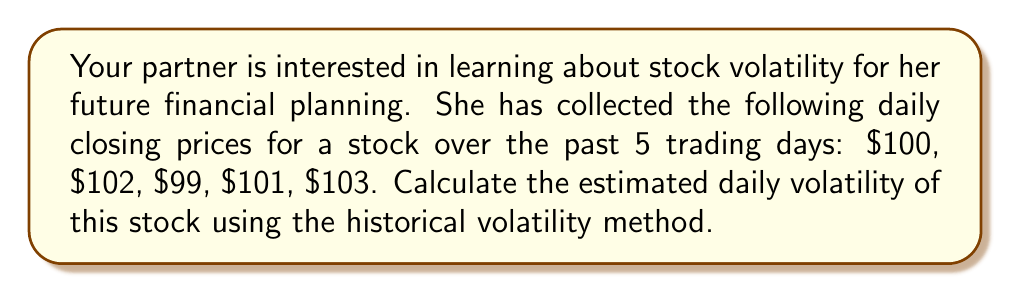Could you help me with this problem? To estimate the daily volatility of a stock using historical price data, we'll follow these steps:

1. Calculate the daily returns:
   $R_t = \ln(\frac{P_t}{P_{t-1}})$
   Where $R_t$ is the return on day t, and $P_t$ is the price on day t.

   $R_1 = \ln(\frac{102}{100}) \approx 0.0198$
   $R_2 = \ln(\frac{99}{102}) \approx -0.0301$
   $R_3 = \ln(\frac{101}{99}) \approx 0.0201$
   $R_4 = \ln(\frac{103}{101}) \approx 0.0198$

2. Calculate the average return:
   $\bar{R} = \frac{1}{n} \sum_{t=1}^n R_t$
   $\bar{R} = \frac{0.0198 + (-0.0301) + 0.0201 + 0.0198}{4} \approx 0.0074$

3. Calculate the squared deviations from the mean:
   $(R_1 - \bar{R})^2 \approx 0.0001536$
   $(R_2 - \bar{R})^2 \approx 0.0014063$
   $(R_3 - \bar{R})^2 \approx 0.0001619$
   $(R_4 - \bar{R})^2 \approx 0.0001536$

4. Calculate the variance:
   $\sigma^2 = \frac{1}{n-1} \sum_{t=1}^n (R_t - \bar{R})^2$
   $\sigma^2 = \frac{0.0001536 + 0.0014063 + 0.0001619 + 0.0001536}{3} \approx 0.0006251$

5. Calculate the standard deviation (volatility):
   $\sigma = \sqrt{\sigma^2} \approx 0.0250$ or 2.50%

This is the estimated daily volatility of the stock based on the given historical price data.
Answer: The estimated daily volatility of the stock is approximately 2.50%. 